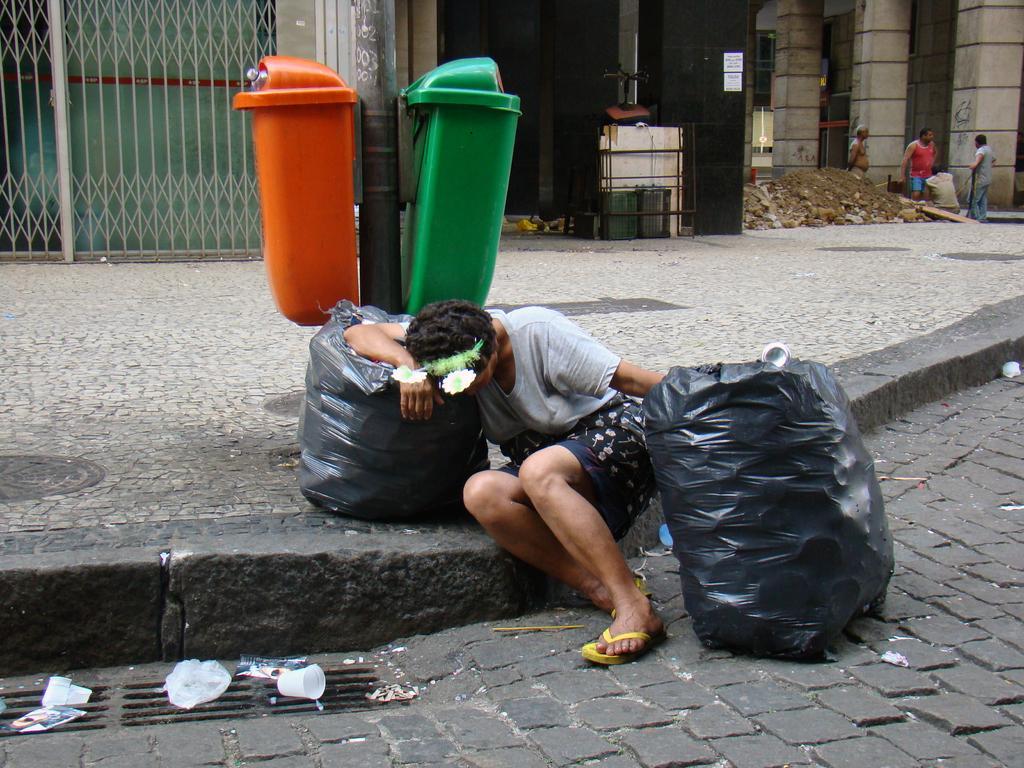In one or two sentences, can you explain what this image depicts? The woman in grey T-shirt is sitting on the footpath. On either side of her, we see garbage bags in black color. Beside her, we see garbage bins in red and green color. On the right side, we see people standing. Beside them, there are pillars. On the left side, we see a grill gate and a building in black color. This picture is clicked in the street and outside the city. 